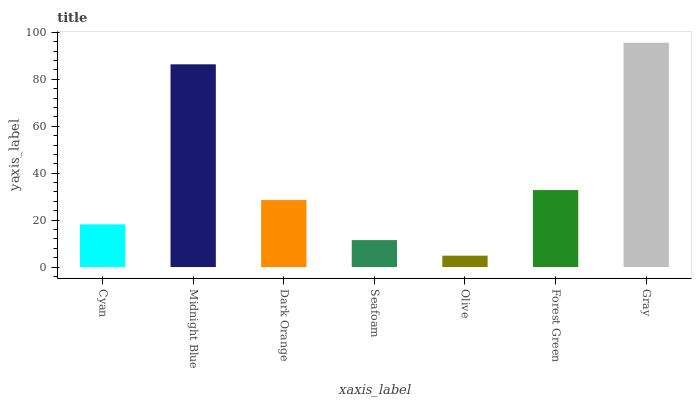Is Olive the minimum?
Answer yes or no. Yes. Is Gray the maximum?
Answer yes or no. Yes. Is Midnight Blue the minimum?
Answer yes or no. No. Is Midnight Blue the maximum?
Answer yes or no. No. Is Midnight Blue greater than Cyan?
Answer yes or no. Yes. Is Cyan less than Midnight Blue?
Answer yes or no. Yes. Is Cyan greater than Midnight Blue?
Answer yes or no. No. Is Midnight Blue less than Cyan?
Answer yes or no. No. Is Dark Orange the high median?
Answer yes or no. Yes. Is Dark Orange the low median?
Answer yes or no. Yes. Is Gray the high median?
Answer yes or no. No. Is Olive the low median?
Answer yes or no. No. 